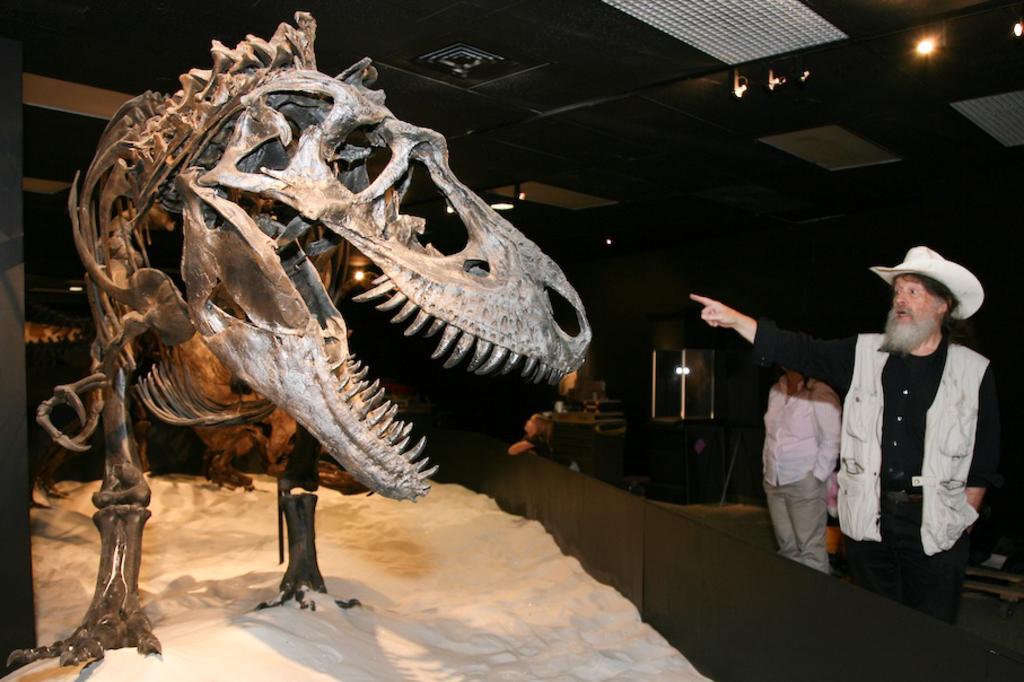Can you describe this image briefly? In this image I can see the skeleton of the dinosaur and I can see two persons standing. In the background I can see few objects and I can also see few lights. 